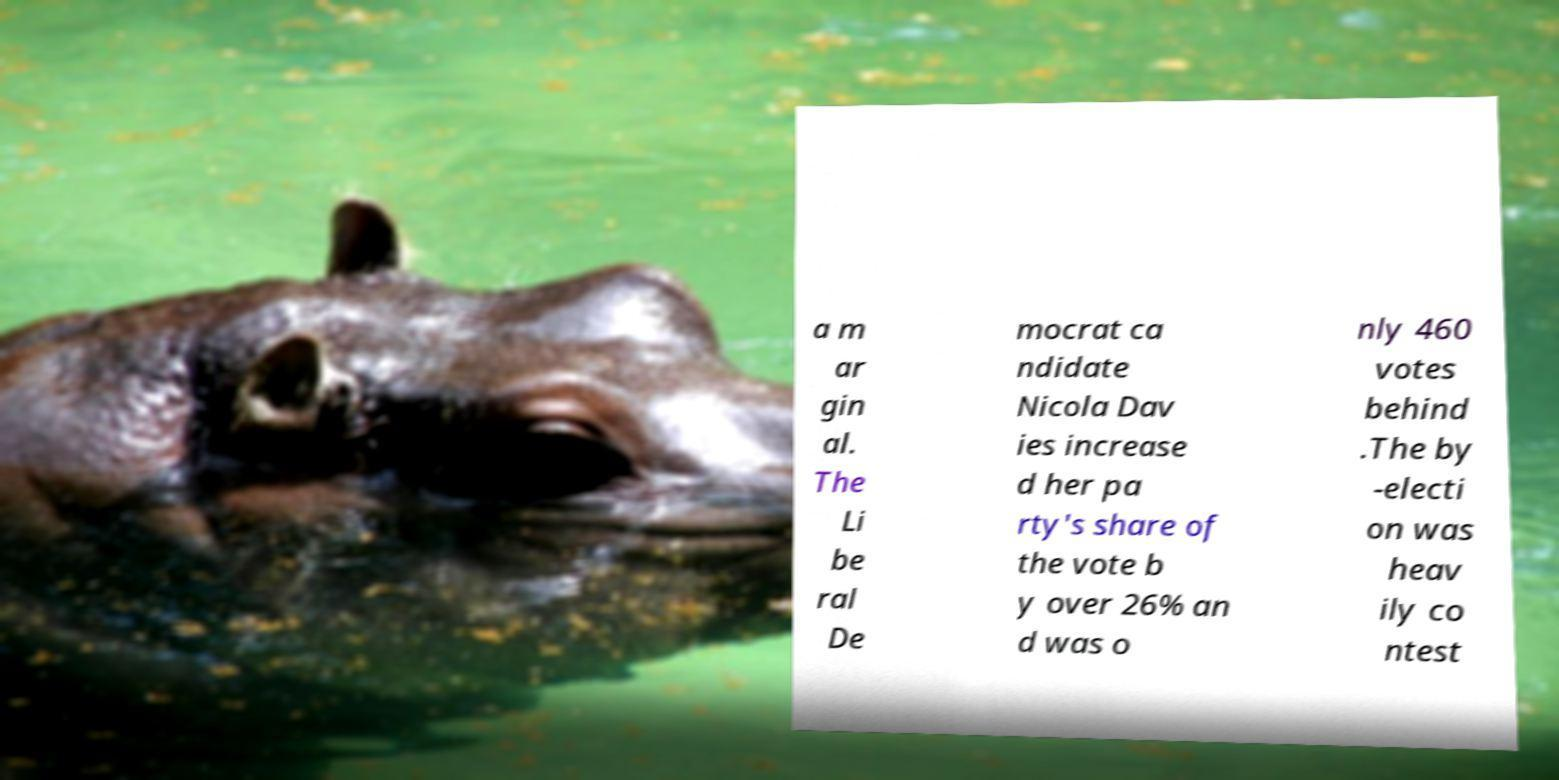There's text embedded in this image that I need extracted. Can you transcribe it verbatim? a m ar gin al. The Li be ral De mocrat ca ndidate Nicola Dav ies increase d her pa rty's share of the vote b y over 26% an d was o nly 460 votes behind .The by -electi on was heav ily co ntest 